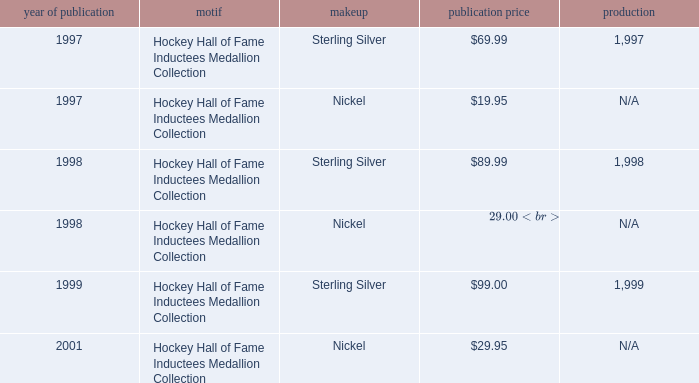How many years was the issue price $19.95? 1.0. 